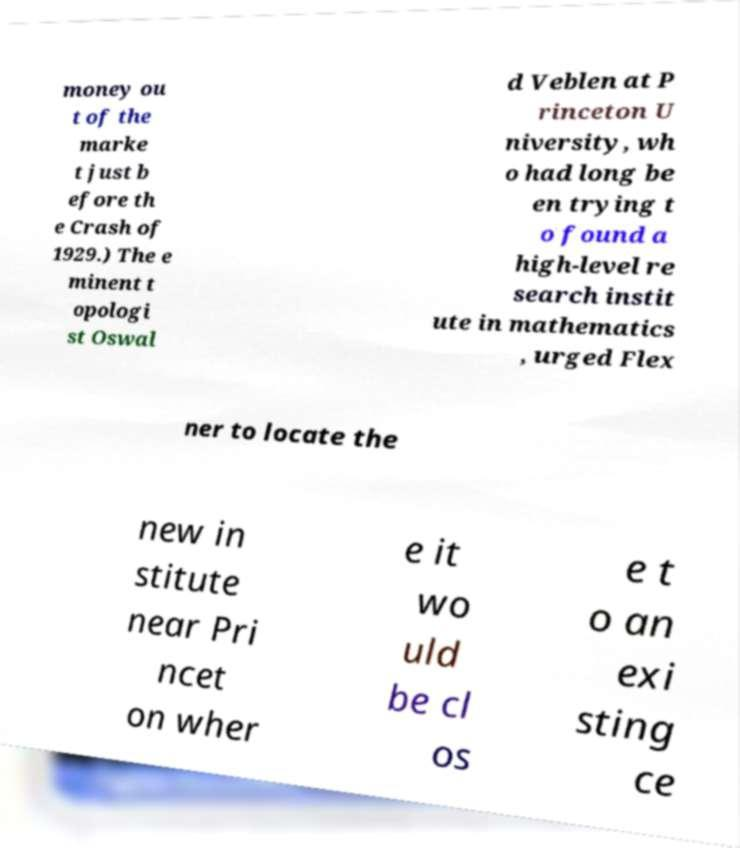Please identify and transcribe the text found in this image. money ou t of the marke t just b efore th e Crash of 1929.) The e minent t opologi st Oswal d Veblen at P rinceton U niversity, wh o had long be en trying t o found a high-level re search instit ute in mathematics , urged Flex ner to locate the new in stitute near Pri ncet on wher e it wo uld be cl os e t o an exi sting ce 